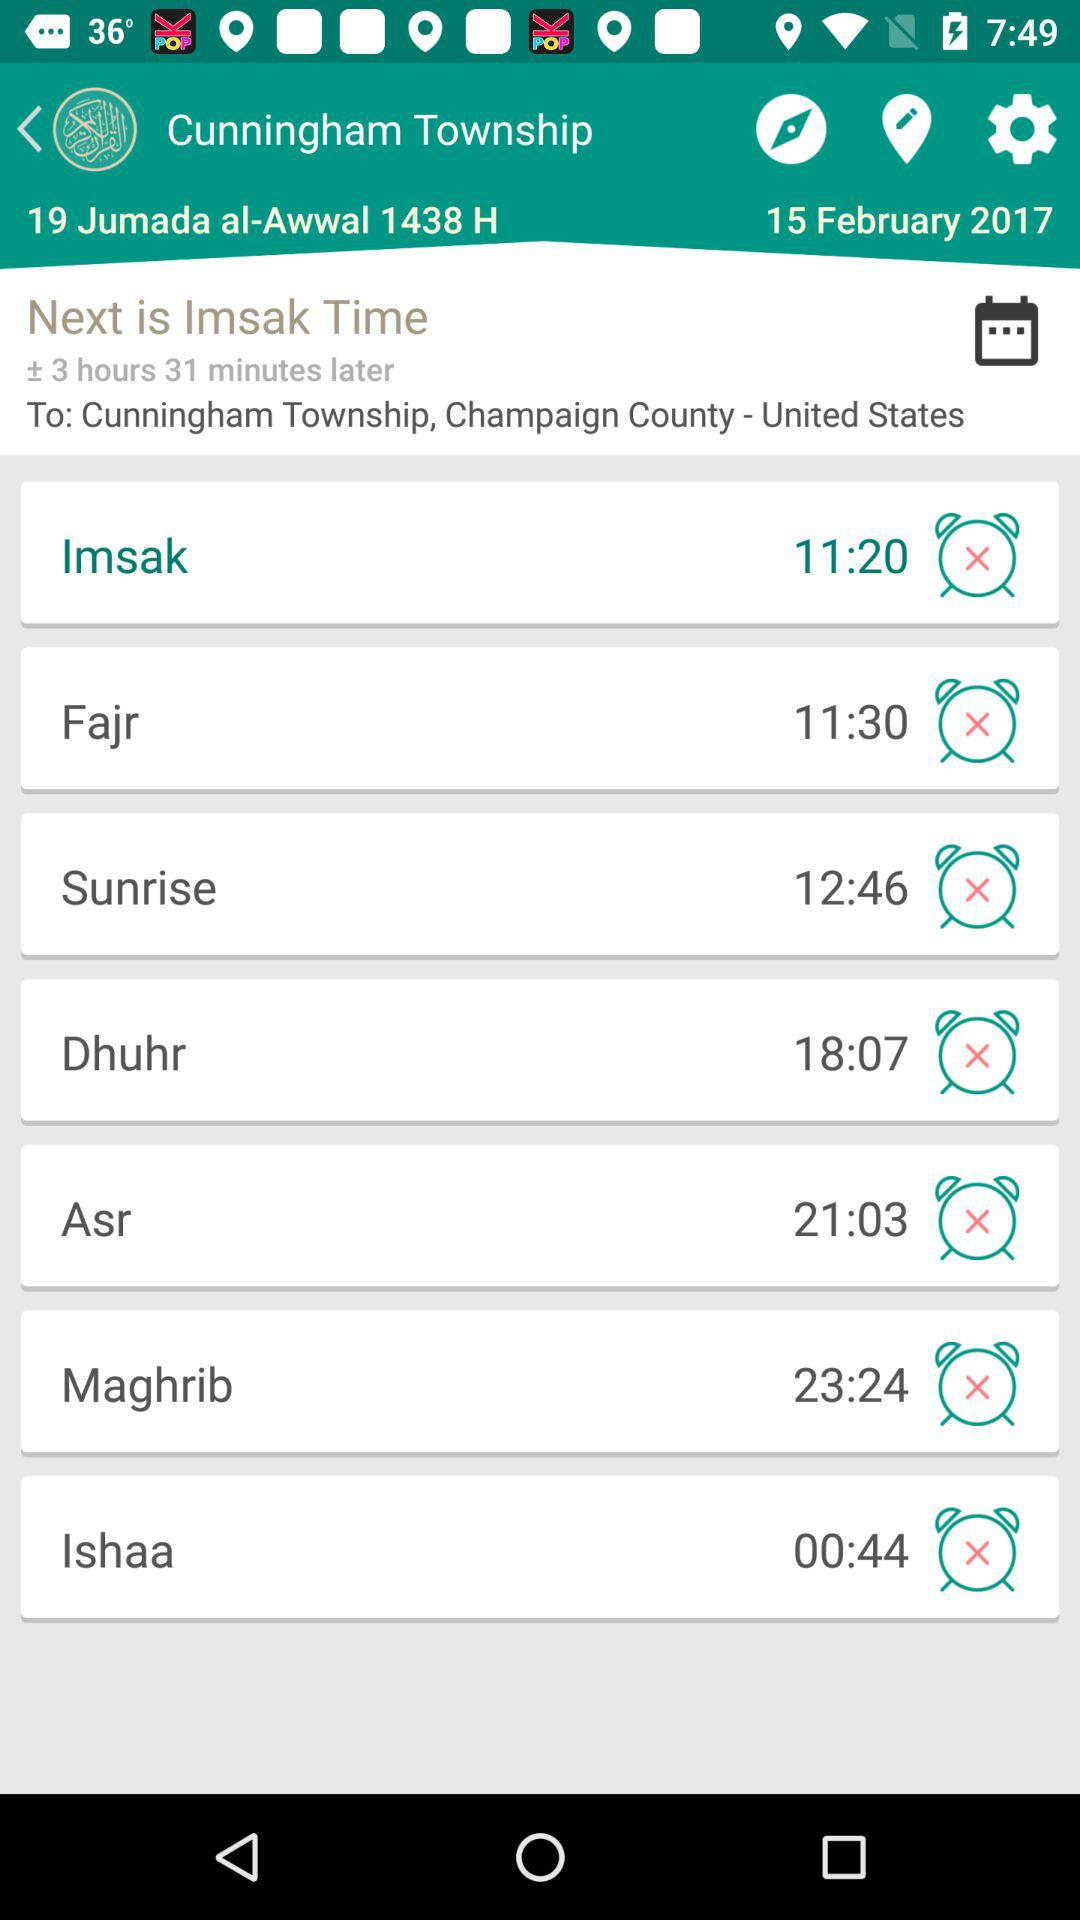How many hours and minutes ahead of UTC is the current time?
Answer the question using a single word or phrase. +3 hours 31 minutes 